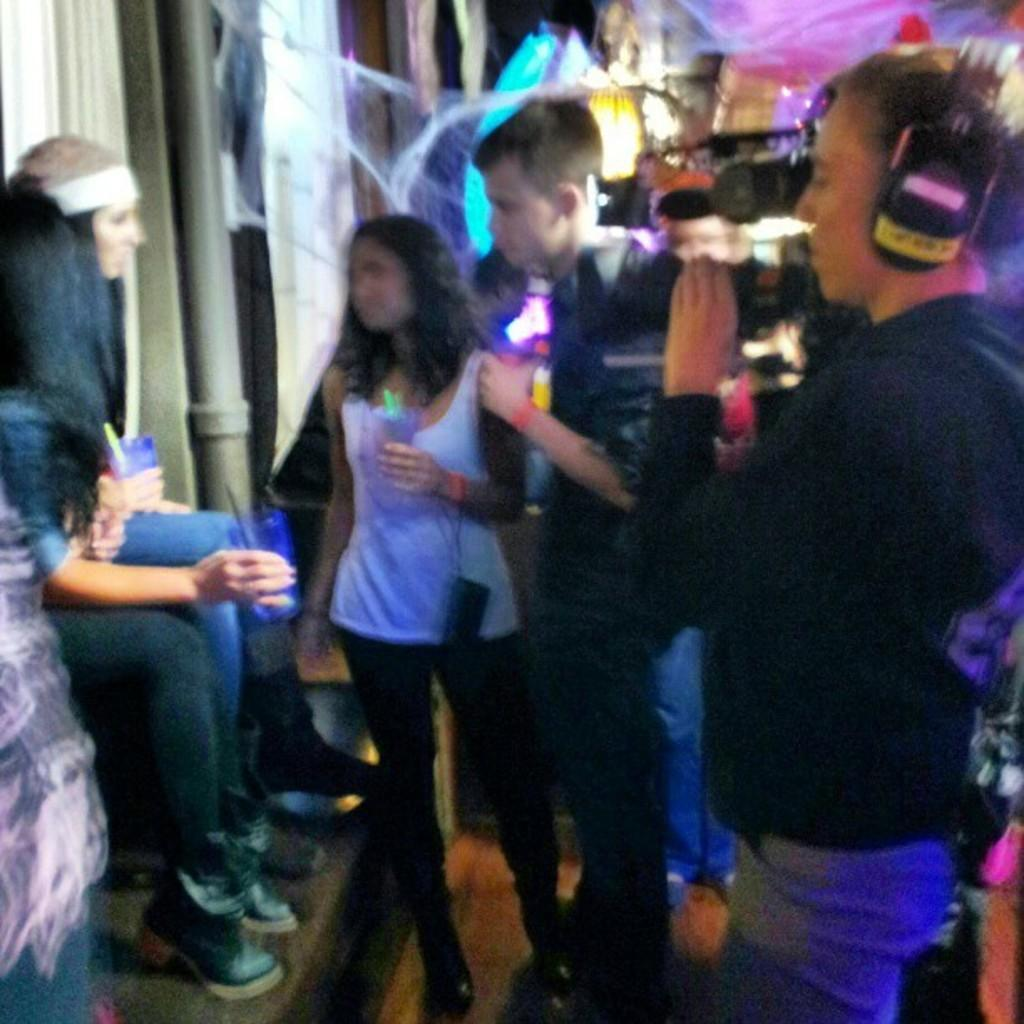What is the person on the right side of the image doing? The person is standing on the right side of the image and holding a camera. What is the person with the camera doing? The person is shooting with the camera. What can be seen on the left side of the image? There are two girls sitting on the left side of the image. What type of minister is teaching the girls in the image? There is no minister or teaching activity present in the image. What color is the gold object being used by the person with the camera? There is no gold object present in the image. 